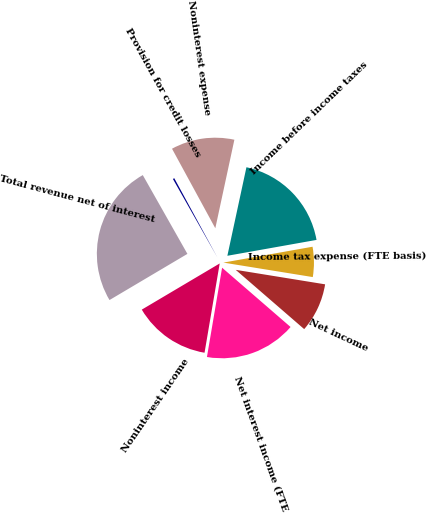Convert chart. <chart><loc_0><loc_0><loc_500><loc_500><pie_chart><fcel>Net interest income (FTE<fcel>Noninterest income<fcel>Total revenue net of interest<fcel>Provision for credit losses<fcel>Noninterest expense<fcel>Income before income taxes<fcel>Income tax expense (FTE basis)<fcel>Net income<nl><fcel>16.32%<fcel>13.81%<fcel>25.31%<fcel>0.27%<fcel>11.31%<fcel>18.82%<fcel>5.36%<fcel>8.8%<nl></chart> 